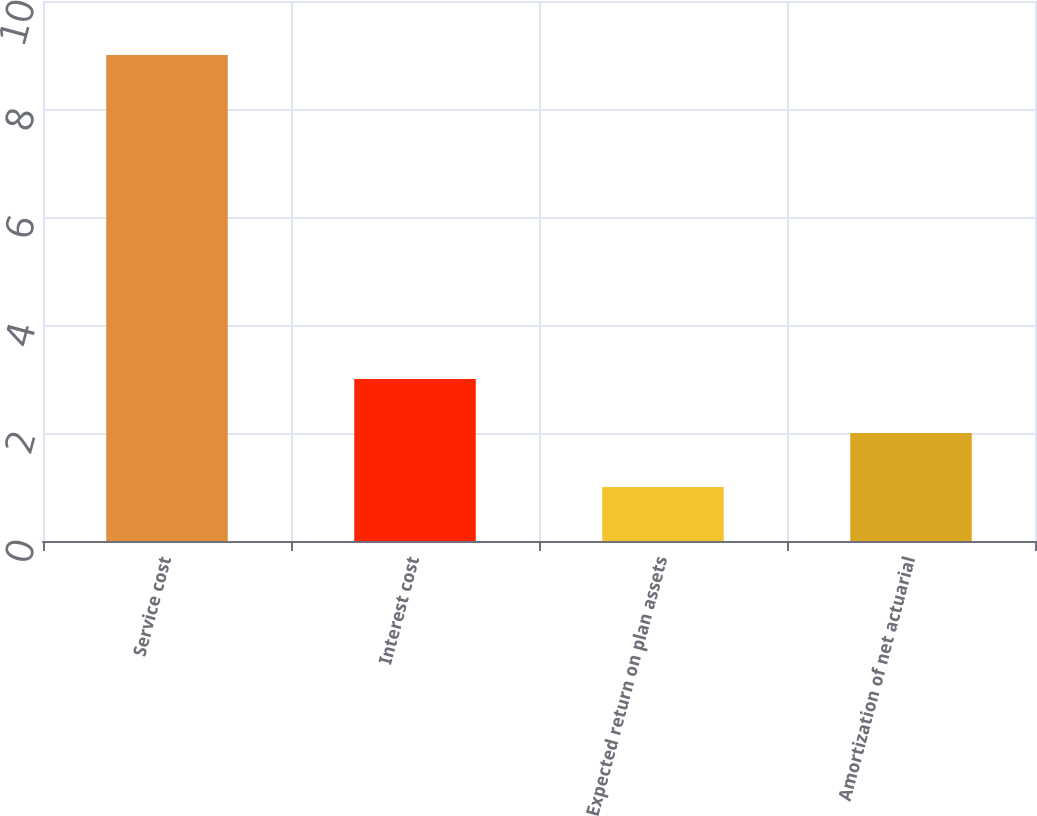Convert chart to OTSL. <chart><loc_0><loc_0><loc_500><loc_500><bar_chart><fcel>Service cost<fcel>Interest cost<fcel>Expected return on plan assets<fcel>Amortization of net actuarial<nl><fcel>9<fcel>3<fcel>1<fcel>2<nl></chart> 